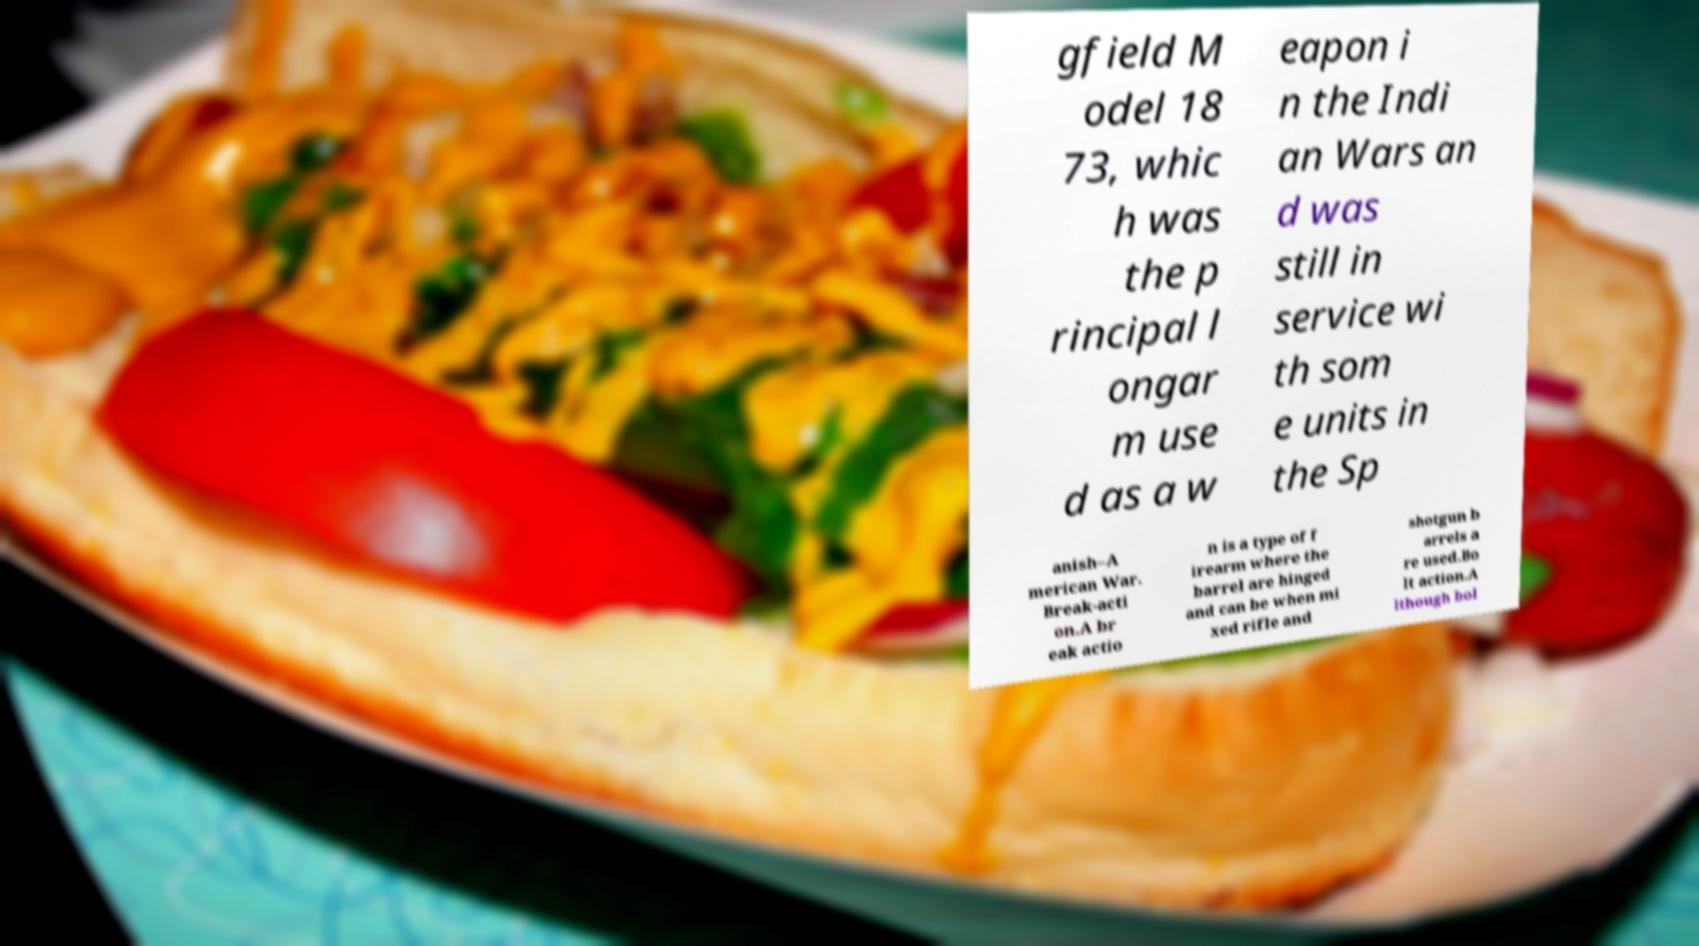Can you accurately transcribe the text from the provided image for me? gfield M odel 18 73, whic h was the p rincipal l ongar m use d as a w eapon i n the Indi an Wars an d was still in service wi th som e units in the Sp anish–A merican War. Break-acti on.A br eak actio n is a type of f irearm where the barrel are hinged and can be when mi xed rifle and shotgun b arrels a re used.Bo lt action.A lthough bol 